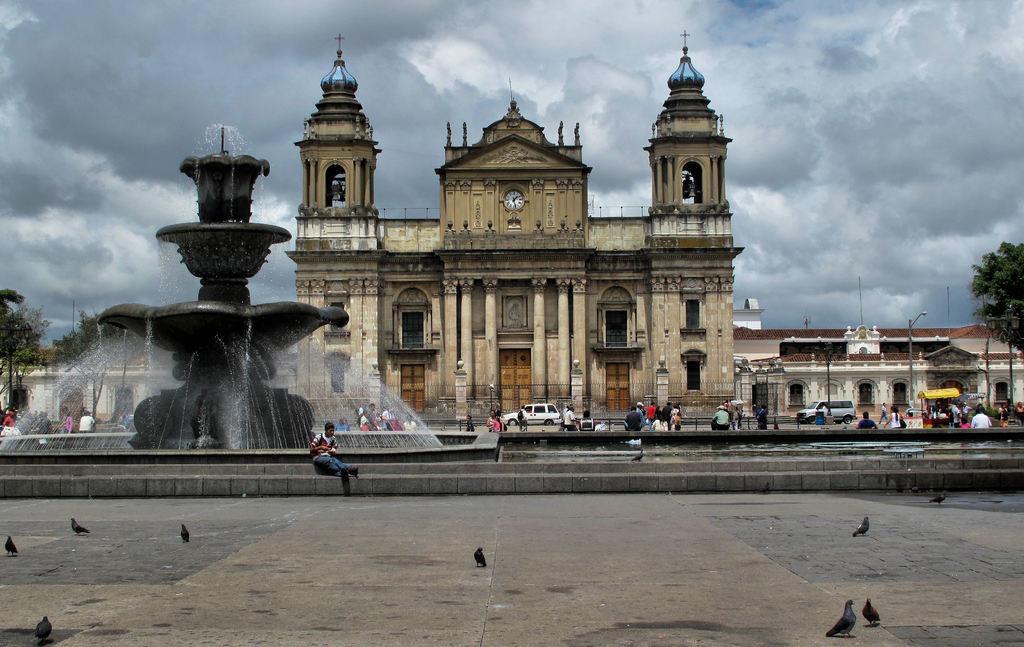Describe this image in one or two sentences. In this image, we can see a houses, building with walls, pillars and windows. Here there are few trees, poles, vehicle. Left side of the image, there is a water fountain. Here we can see few people, birds on the walkway. Top of the image, we can see the clock, bells and cloudy sky. 